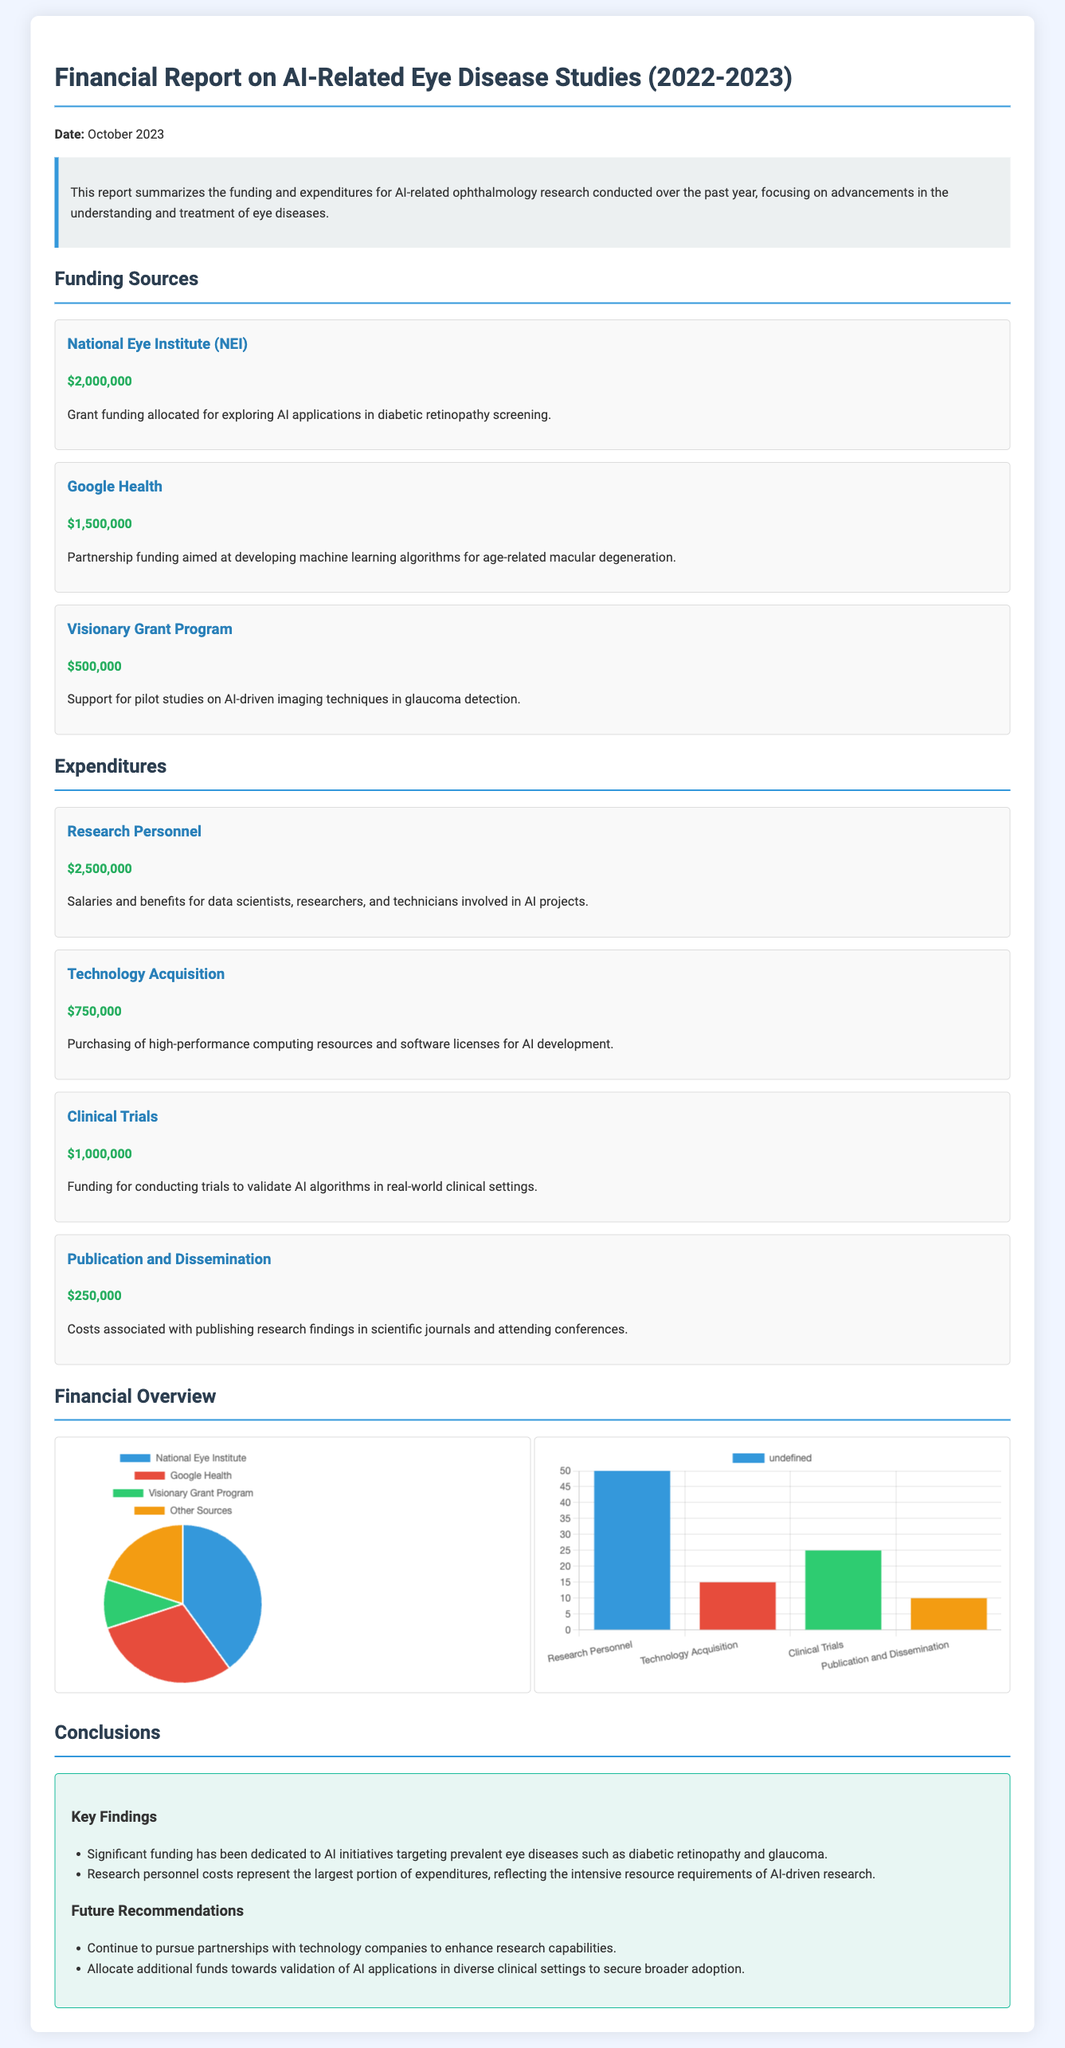What is the total funding from the National Eye Institute? The total funding from the National Eye Institute is specified in the document as $2,000,000.
Answer: $2,000,000 How much was allocated for screening diabetic retinopathy? The funding description mentions that $2,000,000 was allocated for exploring AI applications in diabetic retinopathy screening.
Answer: $2,000,000 What was the largest expenditure category? The document states that Research Personnel caused the largest portion of expenditures at $2,500,000.
Answer: Research Personnel What percentage of funding did Google Health contribute? The funding distribution shows that Google Health contributed 30% of the total funds.
Answer: 30% What is the total expenditure on Clinical Trials? The total expenditure listed for Clinical Trials is $1,000,000.
Answer: $1,000,000 What are the future recommendations related to technology partnerships? The document recommends to continue to pursue partnerships with technology companies.
Answer: Continue to pursue partnerships What was the total funding amount from the Visionary Grant Program? The funding from the Visionary Grant Program is stated as $500,000.
Answer: $500,000 How much was spent on Publication and Dissemination? The report indicates that $250,000 was spent on Publication and Dissemination.
Answer: $250,000 What type of report is this document classified as? This document is classified as a Financial Report.
Answer: Financial Report 